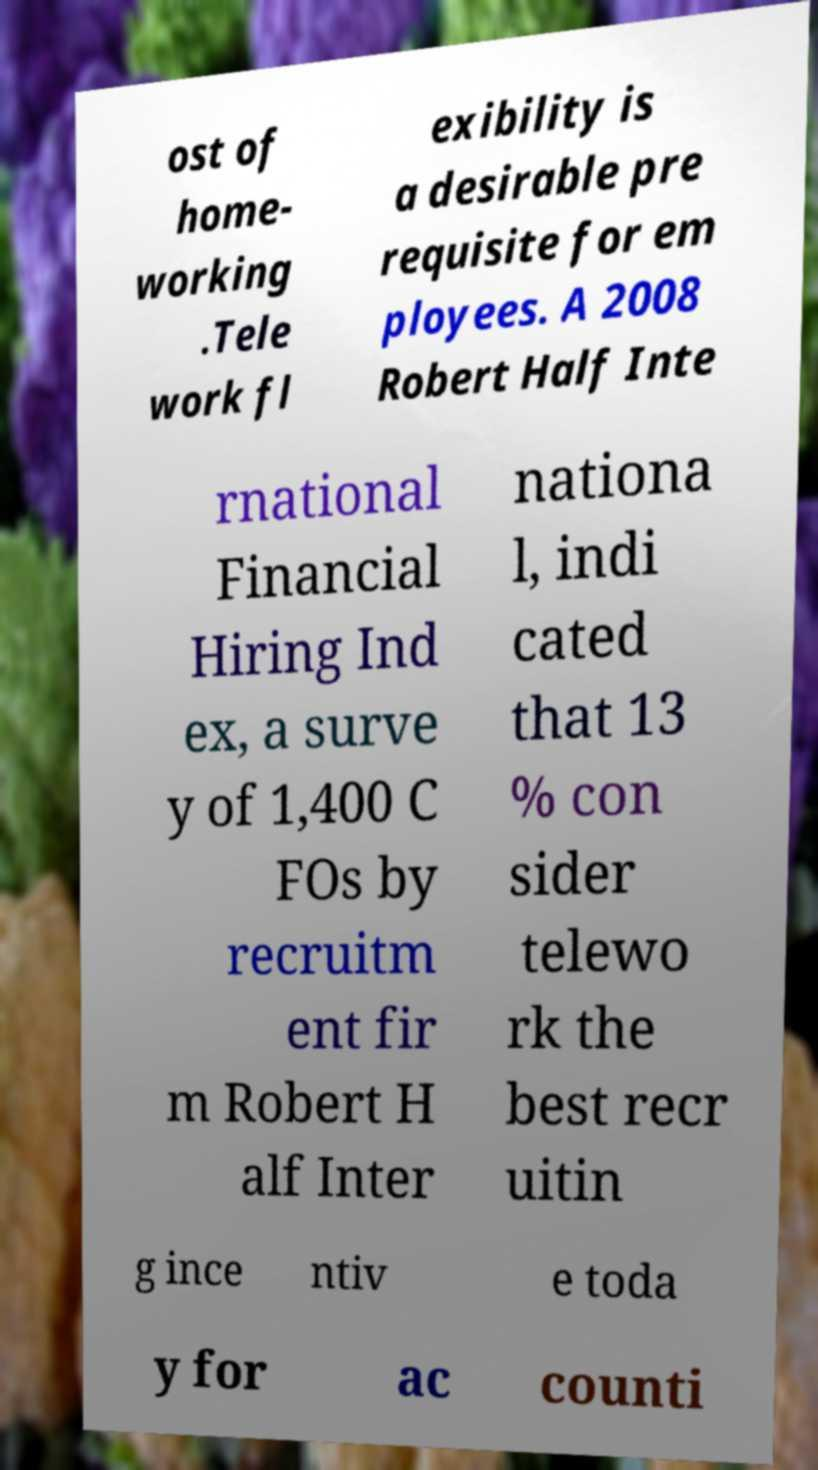There's text embedded in this image that I need extracted. Can you transcribe it verbatim? ost of home- working .Tele work fl exibility is a desirable pre requisite for em ployees. A 2008 Robert Half Inte rnational Financial Hiring Ind ex, a surve y of 1,400 C FOs by recruitm ent fir m Robert H alf Inter nationa l, indi cated that 13 % con sider telewo rk the best recr uitin g ince ntiv e toda y for ac counti 